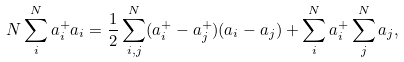Convert formula to latex. <formula><loc_0><loc_0><loc_500><loc_500>N \sum _ { i } ^ { N } a ^ { + } _ { i } a _ { i } = \frac { 1 } { 2 } \sum _ { i , j } ^ { N } ( a ^ { + } _ { i } - a ^ { + } _ { j } ) ( a _ { i } - a _ { j } ) + \sum _ { i } ^ { N } a ^ { + } _ { i } \sum _ { j } ^ { N } a _ { j } ,</formula> 